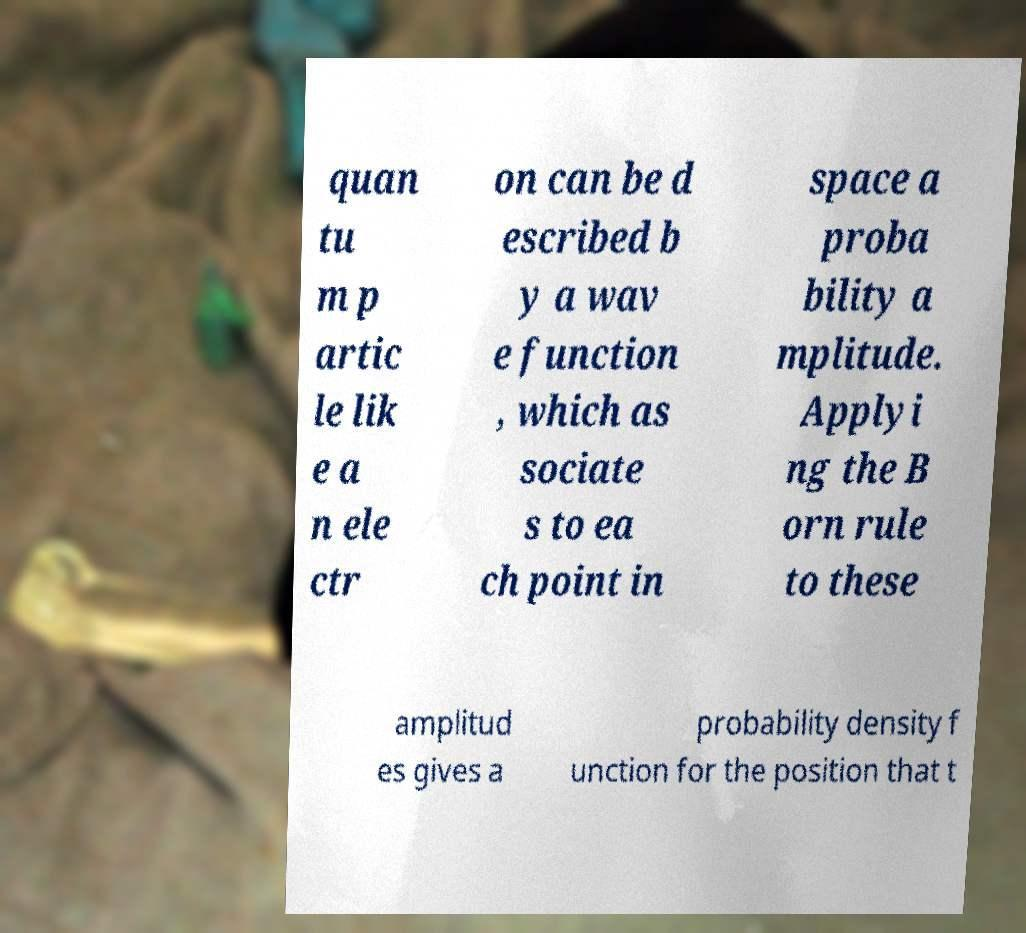There's text embedded in this image that I need extracted. Can you transcribe it verbatim? quan tu m p artic le lik e a n ele ctr on can be d escribed b y a wav e function , which as sociate s to ea ch point in space a proba bility a mplitude. Applyi ng the B orn rule to these amplitud es gives a probability density f unction for the position that t 